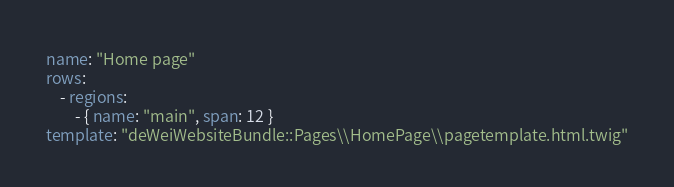<code> <loc_0><loc_0><loc_500><loc_500><_YAML_>name: "Home page"
rows:
    - regions:
        - { name: "main", span: 12 }
template: "deWeiWebsiteBundle::Pages\\HomePage\\pagetemplate.html.twig"
</code> 